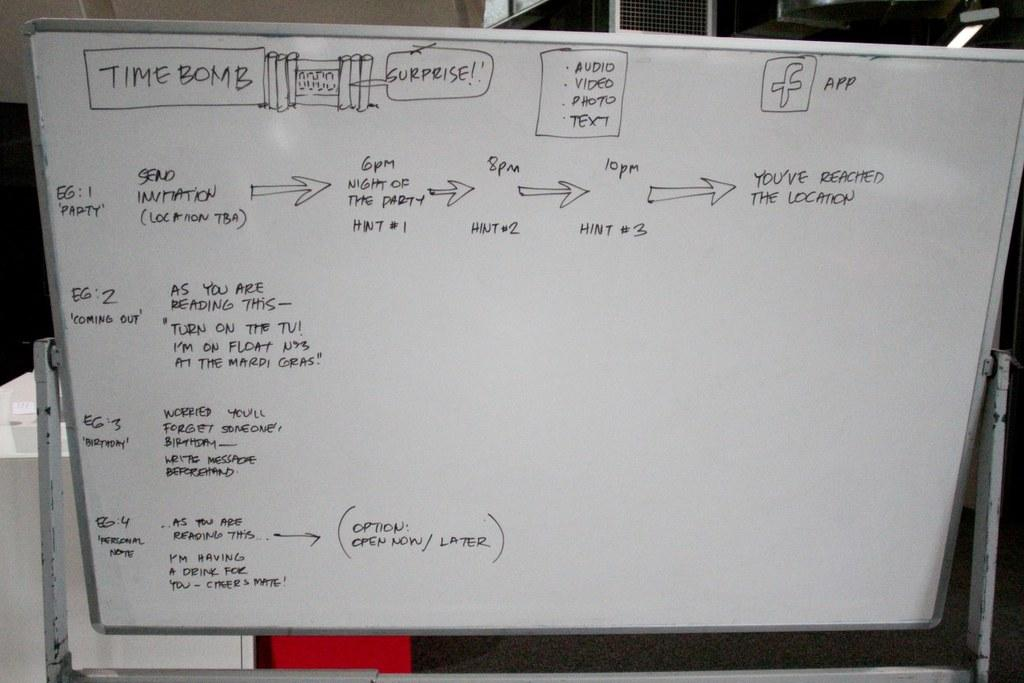<image>
Give a short and clear explanation of the subsequent image. A white board with directions written on it starting with the words Time Bomb. 